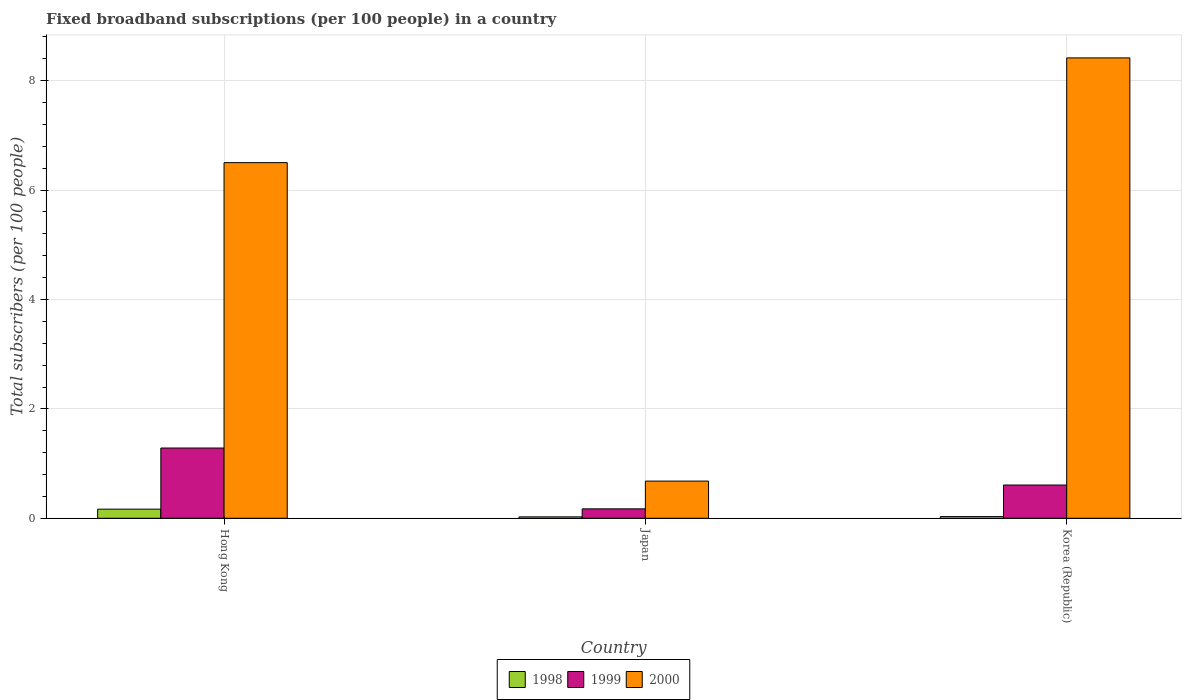How many different coloured bars are there?
Ensure brevity in your answer.  3. Are the number of bars per tick equal to the number of legend labels?
Your response must be concise. Yes. In how many cases, is the number of bars for a given country not equal to the number of legend labels?
Give a very brief answer. 0. What is the number of broadband subscriptions in 1998 in Japan?
Your answer should be very brief. 0.03. Across all countries, what is the maximum number of broadband subscriptions in 2000?
Your answer should be very brief. 8.42. Across all countries, what is the minimum number of broadband subscriptions in 1998?
Your answer should be compact. 0.03. In which country was the number of broadband subscriptions in 1999 maximum?
Keep it short and to the point. Hong Kong. What is the total number of broadband subscriptions in 1998 in the graph?
Provide a short and direct response. 0.22. What is the difference between the number of broadband subscriptions in 1999 in Hong Kong and that in Korea (Republic)?
Your answer should be compact. 0.68. What is the difference between the number of broadband subscriptions in 1999 in Hong Kong and the number of broadband subscriptions in 1998 in Japan?
Offer a very short reply. 1.26. What is the average number of broadband subscriptions in 1999 per country?
Offer a very short reply. 0.69. What is the difference between the number of broadband subscriptions of/in 1998 and number of broadband subscriptions of/in 1999 in Korea (Republic)?
Your response must be concise. -0.58. What is the ratio of the number of broadband subscriptions in 2000 in Hong Kong to that in Korea (Republic)?
Offer a terse response. 0.77. What is the difference between the highest and the second highest number of broadband subscriptions in 2000?
Offer a terse response. 7.74. What is the difference between the highest and the lowest number of broadband subscriptions in 2000?
Provide a short and direct response. 7.74. Is it the case that in every country, the sum of the number of broadband subscriptions in 1998 and number of broadband subscriptions in 1999 is greater than the number of broadband subscriptions in 2000?
Offer a very short reply. No. What is the difference between two consecutive major ticks on the Y-axis?
Offer a very short reply. 2. Are the values on the major ticks of Y-axis written in scientific E-notation?
Offer a very short reply. No. What is the title of the graph?
Ensure brevity in your answer.  Fixed broadband subscriptions (per 100 people) in a country. What is the label or title of the Y-axis?
Your answer should be very brief. Total subscribers (per 100 people). What is the Total subscribers (per 100 people) in 1998 in Hong Kong?
Your answer should be compact. 0.17. What is the Total subscribers (per 100 people) in 1999 in Hong Kong?
Provide a short and direct response. 1.28. What is the Total subscribers (per 100 people) of 2000 in Hong Kong?
Your answer should be very brief. 6.5. What is the Total subscribers (per 100 people) in 1998 in Japan?
Ensure brevity in your answer.  0.03. What is the Total subscribers (per 100 people) of 1999 in Japan?
Give a very brief answer. 0.17. What is the Total subscribers (per 100 people) of 2000 in Japan?
Your response must be concise. 0.68. What is the Total subscribers (per 100 people) of 1998 in Korea (Republic)?
Ensure brevity in your answer.  0.03. What is the Total subscribers (per 100 people) in 1999 in Korea (Republic)?
Offer a terse response. 0.61. What is the Total subscribers (per 100 people) in 2000 in Korea (Republic)?
Your answer should be very brief. 8.42. Across all countries, what is the maximum Total subscribers (per 100 people) in 1998?
Provide a short and direct response. 0.17. Across all countries, what is the maximum Total subscribers (per 100 people) in 1999?
Keep it short and to the point. 1.28. Across all countries, what is the maximum Total subscribers (per 100 people) of 2000?
Ensure brevity in your answer.  8.42. Across all countries, what is the minimum Total subscribers (per 100 people) of 1998?
Keep it short and to the point. 0.03. Across all countries, what is the minimum Total subscribers (per 100 people) of 1999?
Give a very brief answer. 0.17. Across all countries, what is the minimum Total subscribers (per 100 people) in 2000?
Make the answer very short. 0.68. What is the total Total subscribers (per 100 people) of 1998 in the graph?
Provide a succinct answer. 0.22. What is the total Total subscribers (per 100 people) of 1999 in the graph?
Your answer should be very brief. 2.06. What is the total Total subscribers (per 100 people) in 2000 in the graph?
Provide a succinct answer. 15.6. What is the difference between the Total subscribers (per 100 people) in 1998 in Hong Kong and that in Japan?
Your response must be concise. 0.14. What is the difference between the Total subscribers (per 100 people) in 1999 in Hong Kong and that in Japan?
Your answer should be very brief. 1.11. What is the difference between the Total subscribers (per 100 people) of 2000 in Hong Kong and that in Japan?
Provide a short and direct response. 5.82. What is the difference between the Total subscribers (per 100 people) in 1998 in Hong Kong and that in Korea (Republic)?
Make the answer very short. 0.14. What is the difference between the Total subscribers (per 100 people) of 1999 in Hong Kong and that in Korea (Republic)?
Give a very brief answer. 0.68. What is the difference between the Total subscribers (per 100 people) of 2000 in Hong Kong and that in Korea (Republic)?
Your response must be concise. -1.91. What is the difference between the Total subscribers (per 100 people) of 1998 in Japan and that in Korea (Republic)?
Your answer should be compact. -0.01. What is the difference between the Total subscribers (per 100 people) of 1999 in Japan and that in Korea (Republic)?
Offer a very short reply. -0.44. What is the difference between the Total subscribers (per 100 people) in 2000 in Japan and that in Korea (Republic)?
Give a very brief answer. -7.74. What is the difference between the Total subscribers (per 100 people) of 1998 in Hong Kong and the Total subscribers (per 100 people) of 1999 in Japan?
Ensure brevity in your answer.  -0.01. What is the difference between the Total subscribers (per 100 people) in 1998 in Hong Kong and the Total subscribers (per 100 people) in 2000 in Japan?
Your answer should be compact. -0.51. What is the difference between the Total subscribers (per 100 people) of 1999 in Hong Kong and the Total subscribers (per 100 people) of 2000 in Japan?
Provide a succinct answer. 0.6. What is the difference between the Total subscribers (per 100 people) of 1998 in Hong Kong and the Total subscribers (per 100 people) of 1999 in Korea (Republic)?
Offer a terse response. -0.44. What is the difference between the Total subscribers (per 100 people) in 1998 in Hong Kong and the Total subscribers (per 100 people) in 2000 in Korea (Republic)?
Provide a succinct answer. -8.25. What is the difference between the Total subscribers (per 100 people) in 1999 in Hong Kong and the Total subscribers (per 100 people) in 2000 in Korea (Republic)?
Keep it short and to the point. -7.13. What is the difference between the Total subscribers (per 100 people) of 1998 in Japan and the Total subscribers (per 100 people) of 1999 in Korea (Republic)?
Offer a terse response. -0.58. What is the difference between the Total subscribers (per 100 people) of 1998 in Japan and the Total subscribers (per 100 people) of 2000 in Korea (Republic)?
Offer a terse response. -8.39. What is the difference between the Total subscribers (per 100 people) of 1999 in Japan and the Total subscribers (per 100 people) of 2000 in Korea (Republic)?
Keep it short and to the point. -8.25. What is the average Total subscribers (per 100 people) in 1998 per country?
Keep it short and to the point. 0.07. What is the average Total subscribers (per 100 people) in 1999 per country?
Your answer should be compact. 0.69. What is the average Total subscribers (per 100 people) in 2000 per country?
Your response must be concise. 5.2. What is the difference between the Total subscribers (per 100 people) in 1998 and Total subscribers (per 100 people) in 1999 in Hong Kong?
Make the answer very short. -1.12. What is the difference between the Total subscribers (per 100 people) in 1998 and Total subscribers (per 100 people) in 2000 in Hong Kong?
Make the answer very short. -6.34. What is the difference between the Total subscribers (per 100 people) in 1999 and Total subscribers (per 100 people) in 2000 in Hong Kong?
Your response must be concise. -5.22. What is the difference between the Total subscribers (per 100 people) of 1998 and Total subscribers (per 100 people) of 1999 in Japan?
Keep it short and to the point. -0.15. What is the difference between the Total subscribers (per 100 people) in 1998 and Total subscribers (per 100 people) in 2000 in Japan?
Keep it short and to the point. -0.65. What is the difference between the Total subscribers (per 100 people) in 1999 and Total subscribers (per 100 people) in 2000 in Japan?
Your answer should be compact. -0.51. What is the difference between the Total subscribers (per 100 people) of 1998 and Total subscribers (per 100 people) of 1999 in Korea (Republic)?
Offer a very short reply. -0.58. What is the difference between the Total subscribers (per 100 people) in 1998 and Total subscribers (per 100 people) in 2000 in Korea (Republic)?
Offer a very short reply. -8.39. What is the difference between the Total subscribers (per 100 people) in 1999 and Total subscribers (per 100 people) in 2000 in Korea (Republic)?
Your answer should be compact. -7.81. What is the ratio of the Total subscribers (per 100 people) in 1998 in Hong Kong to that in Japan?
Keep it short and to the point. 6.53. What is the ratio of the Total subscribers (per 100 people) of 1999 in Hong Kong to that in Japan?
Your answer should be compact. 7.46. What is the ratio of the Total subscribers (per 100 people) of 2000 in Hong Kong to that in Japan?
Ensure brevity in your answer.  9.56. What is the ratio of the Total subscribers (per 100 people) of 1998 in Hong Kong to that in Korea (Republic)?
Offer a terse response. 5.42. What is the ratio of the Total subscribers (per 100 people) of 1999 in Hong Kong to that in Korea (Republic)?
Offer a terse response. 2.11. What is the ratio of the Total subscribers (per 100 people) of 2000 in Hong Kong to that in Korea (Republic)?
Ensure brevity in your answer.  0.77. What is the ratio of the Total subscribers (per 100 people) of 1998 in Japan to that in Korea (Republic)?
Your response must be concise. 0.83. What is the ratio of the Total subscribers (per 100 people) in 1999 in Japan to that in Korea (Republic)?
Your answer should be very brief. 0.28. What is the ratio of the Total subscribers (per 100 people) of 2000 in Japan to that in Korea (Republic)?
Make the answer very short. 0.08. What is the difference between the highest and the second highest Total subscribers (per 100 people) of 1998?
Ensure brevity in your answer.  0.14. What is the difference between the highest and the second highest Total subscribers (per 100 people) of 1999?
Your answer should be compact. 0.68. What is the difference between the highest and the second highest Total subscribers (per 100 people) in 2000?
Your response must be concise. 1.91. What is the difference between the highest and the lowest Total subscribers (per 100 people) in 1998?
Offer a very short reply. 0.14. What is the difference between the highest and the lowest Total subscribers (per 100 people) in 1999?
Ensure brevity in your answer.  1.11. What is the difference between the highest and the lowest Total subscribers (per 100 people) in 2000?
Ensure brevity in your answer.  7.74. 